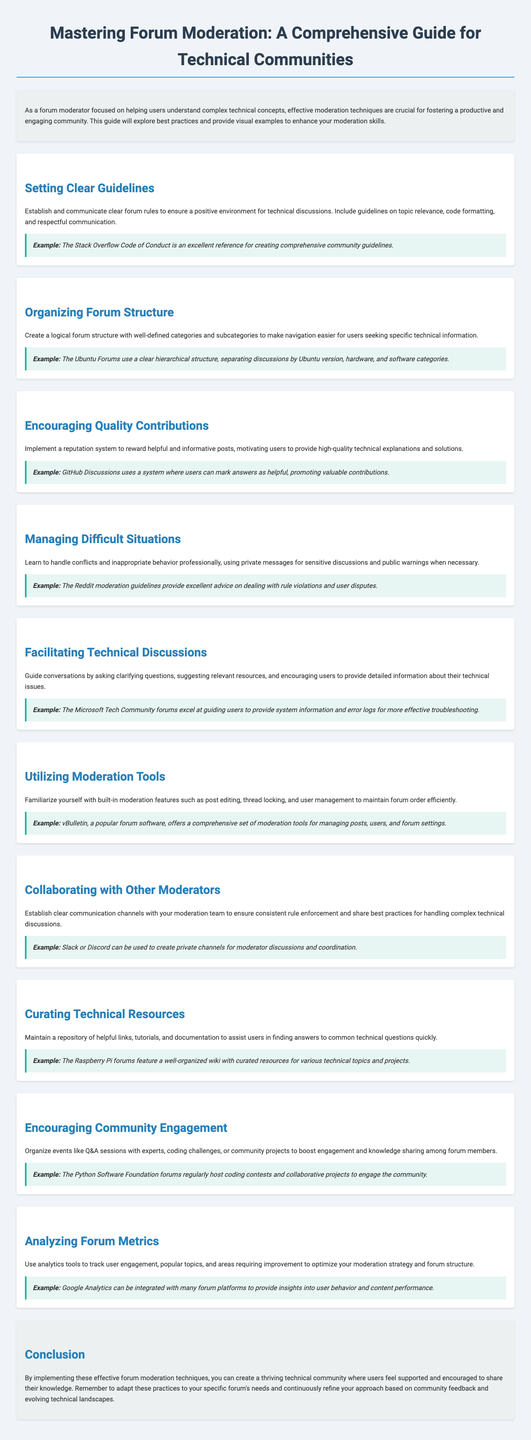what is the title of the document? The title is a prominent feature of the brochure that indicates its main subject.
Answer: Mastering Forum Moderation: A Comprehensive Guide for Technical Communities what is the focus of the introduction? The introduction outlines the importance of effective moderation techniques for fostering a productive and engaging community.
Answer: Helping users understand complex technical concepts what is the first section of the document? The first section lays the groundwork for effective moderation by establishing rules.
Answer: Setting Clear Guidelines which forum is mentioned as a reference for community guidelines? This example highlights best practices in creating effective moderation rules.
Answer: The Stack Overflow Code of Conduct what tool is suggested for tracking user engagement? This tool is critical for analyzing forum metrics and optimizing moderation strategies.
Answer: Google Analytics how can moderators handle conflicts according to the document? This guideline emphasizes the importance of professional communication in sensitive situations.
Answer: Using private messages for sensitive discussions what is one method suggested for encouraging community engagement? This is an approach to promote interaction among forum members and enhance learning.
Answer: Organizing events like Q&A sessions what does the document recommend for organizing forums? This is essential for improving user navigation and access to technical information.
Answer: Create a logical forum structure how can moderators collaborate effectively according to the content? This approach ensures consistency in rule enforcement among the moderation team.
Answer: Establish clear communication channels 